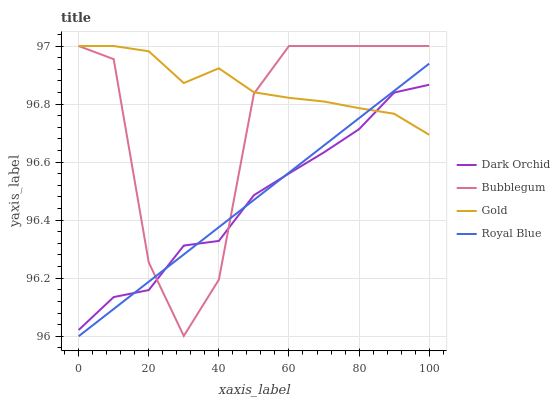Does Dark Orchid have the minimum area under the curve?
Answer yes or no. Yes. Does Gold have the maximum area under the curve?
Answer yes or no. Yes. Does Bubblegum have the minimum area under the curve?
Answer yes or no. No. Does Bubblegum have the maximum area under the curve?
Answer yes or no. No. Is Royal Blue the smoothest?
Answer yes or no. Yes. Is Bubblegum the roughest?
Answer yes or no. Yes. Is Dark Orchid the smoothest?
Answer yes or no. No. Is Dark Orchid the roughest?
Answer yes or no. No. Does Royal Blue have the lowest value?
Answer yes or no. Yes. Does Bubblegum have the lowest value?
Answer yes or no. No. Does Bubblegum have the highest value?
Answer yes or no. Yes. Does Dark Orchid have the highest value?
Answer yes or no. No. Does Royal Blue intersect Bubblegum?
Answer yes or no. Yes. Is Royal Blue less than Bubblegum?
Answer yes or no. No. Is Royal Blue greater than Bubblegum?
Answer yes or no. No. 